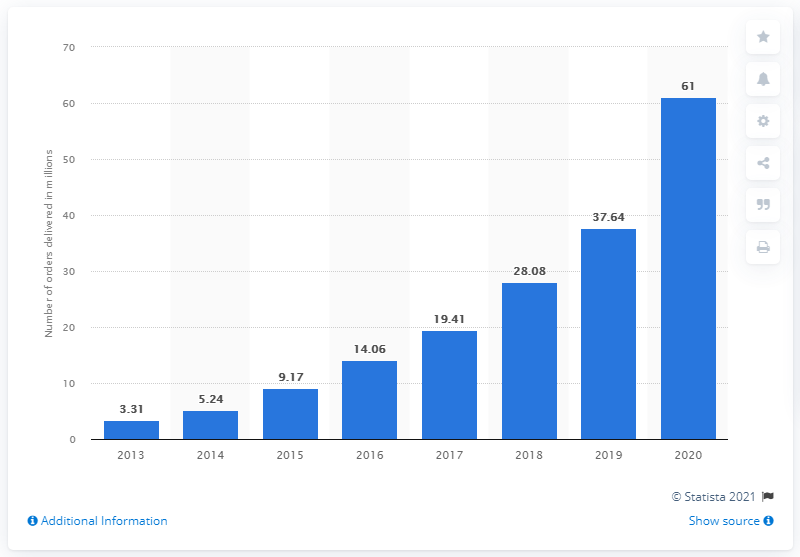Highlight a few significant elements in this photo. Wayfair delivered 61 orders during the last fiscal period. In the previous year, Wayfair received a total of 37,640 orders. 